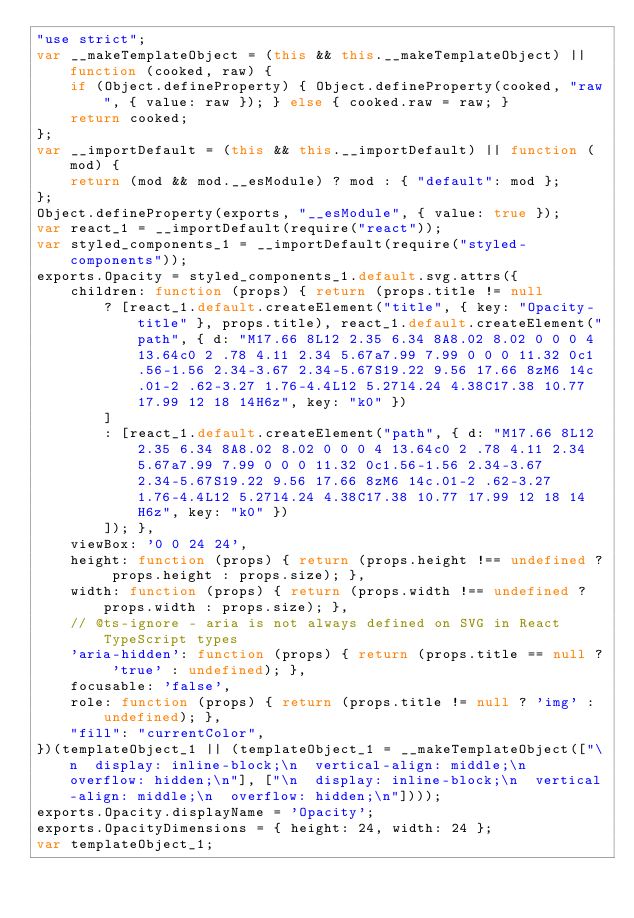Convert code to text. <code><loc_0><loc_0><loc_500><loc_500><_JavaScript_>"use strict";
var __makeTemplateObject = (this && this.__makeTemplateObject) || function (cooked, raw) {
    if (Object.defineProperty) { Object.defineProperty(cooked, "raw", { value: raw }); } else { cooked.raw = raw; }
    return cooked;
};
var __importDefault = (this && this.__importDefault) || function (mod) {
    return (mod && mod.__esModule) ? mod : { "default": mod };
};
Object.defineProperty(exports, "__esModule", { value: true });
var react_1 = __importDefault(require("react"));
var styled_components_1 = __importDefault(require("styled-components"));
exports.Opacity = styled_components_1.default.svg.attrs({
    children: function (props) { return (props.title != null
        ? [react_1.default.createElement("title", { key: "Opacity-title" }, props.title), react_1.default.createElement("path", { d: "M17.66 8L12 2.35 6.34 8A8.02 8.02 0 0 0 4 13.64c0 2 .78 4.11 2.34 5.67a7.99 7.99 0 0 0 11.32 0c1.56-1.56 2.34-3.67 2.34-5.67S19.22 9.56 17.66 8zM6 14c.01-2 .62-3.27 1.76-4.4L12 5.27l4.24 4.38C17.38 10.77 17.99 12 18 14H6z", key: "k0" })
        ]
        : [react_1.default.createElement("path", { d: "M17.66 8L12 2.35 6.34 8A8.02 8.02 0 0 0 4 13.64c0 2 .78 4.11 2.34 5.67a7.99 7.99 0 0 0 11.32 0c1.56-1.56 2.34-3.67 2.34-5.67S19.22 9.56 17.66 8zM6 14c.01-2 .62-3.27 1.76-4.4L12 5.27l4.24 4.38C17.38 10.77 17.99 12 18 14H6z", key: "k0" })
        ]); },
    viewBox: '0 0 24 24',
    height: function (props) { return (props.height !== undefined ? props.height : props.size); },
    width: function (props) { return (props.width !== undefined ? props.width : props.size); },
    // @ts-ignore - aria is not always defined on SVG in React TypeScript types
    'aria-hidden': function (props) { return (props.title == null ? 'true' : undefined); },
    focusable: 'false',
    role: function (props) { return (props.title != null ? 'img' : undefined); },
    "fill": "currentColor",
})(templateObject_1 || (templateObject_1 = __makeTemplateObject(["\n  display: inline-block;\n  vertical-align: middle;\n  overflow: hidden;\n"], ["\n  display: inline-block;\n  vertical-align: middle;\n  overflow: hidden;\n"])));
exports.Opacity.displayName = 'Opacity';
exports.OpacityDimensions = { height: 24, width: 24 };
var templateObject_1;
</code> 